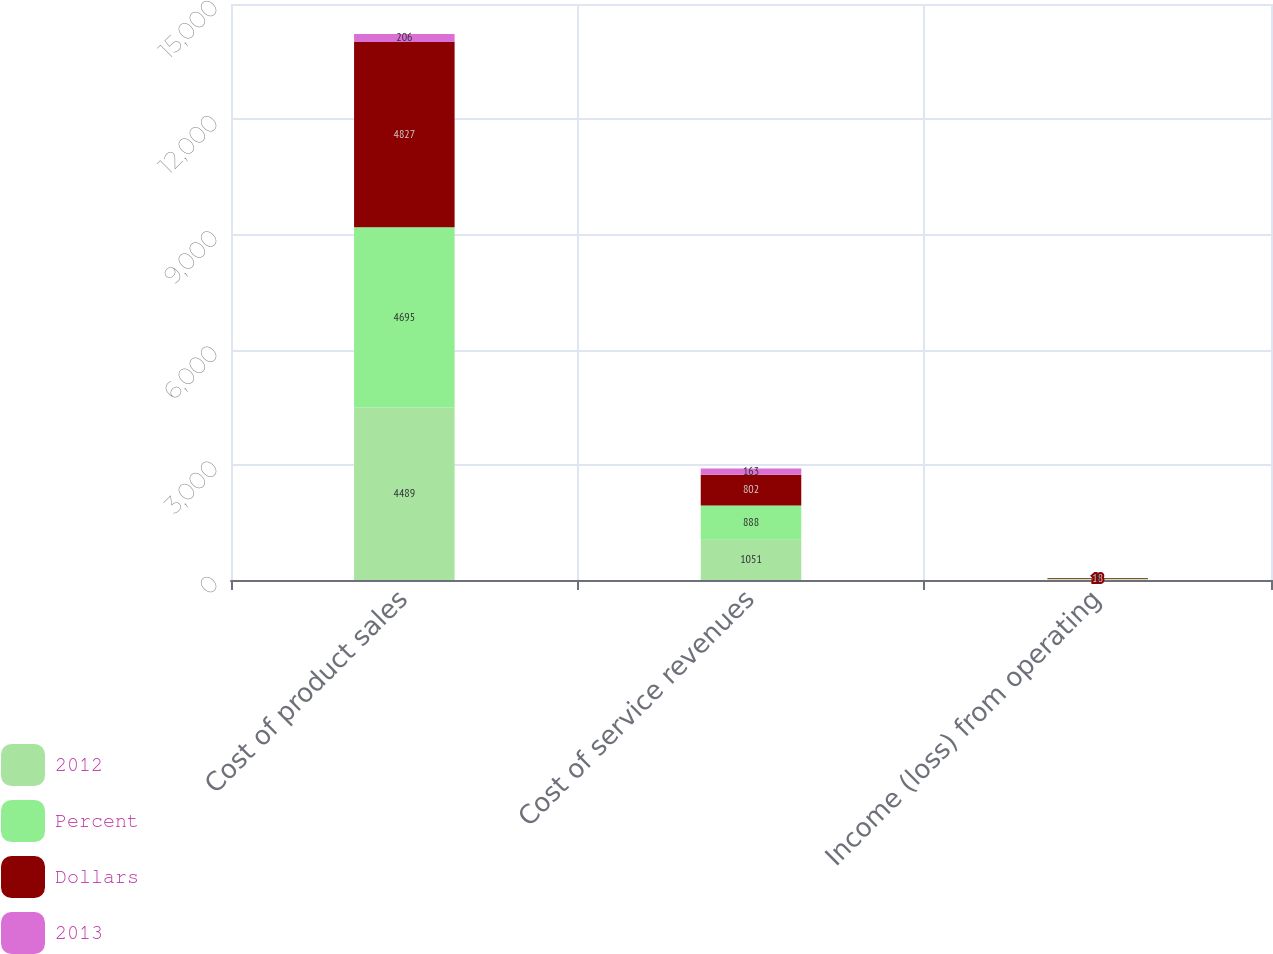Convert chart to OTSL. <chart><loc_0><loc_0><loc_500><loc_500><stacked_bar_chart><ecel><fcel>Cost of product sales<fcel>Cost of service revenues<fcel>Income (loss) from operating<nl><fcel>2012<fcel>4489<fcel>1051<fcel>11<nl><fcel>Percent<fcel>4695<fcel>888<fcel>14<nl><fcel>Dollars<fcel>4827<fcel>802<fcel>18<nl><fcel>2013<fcel>206<fcel>163<fcel>3<nl></chart> 